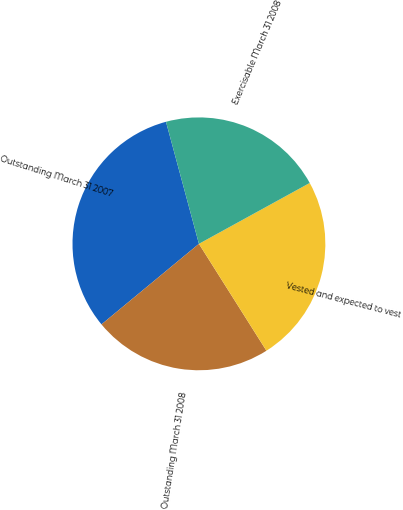<chart> <loc_0><loc_0><loc_500><loc_500><pie_chart><fcel>Outstanding March 31 2007<fcel>Outstanding March 31 2008<fcel>Vested and expected to vest<fcel>Exercisable March 31 2008<nl><fcel>31.8%<fcel>22.97%<fcel>24.03%<fcel>21.2%<nl></chart> 